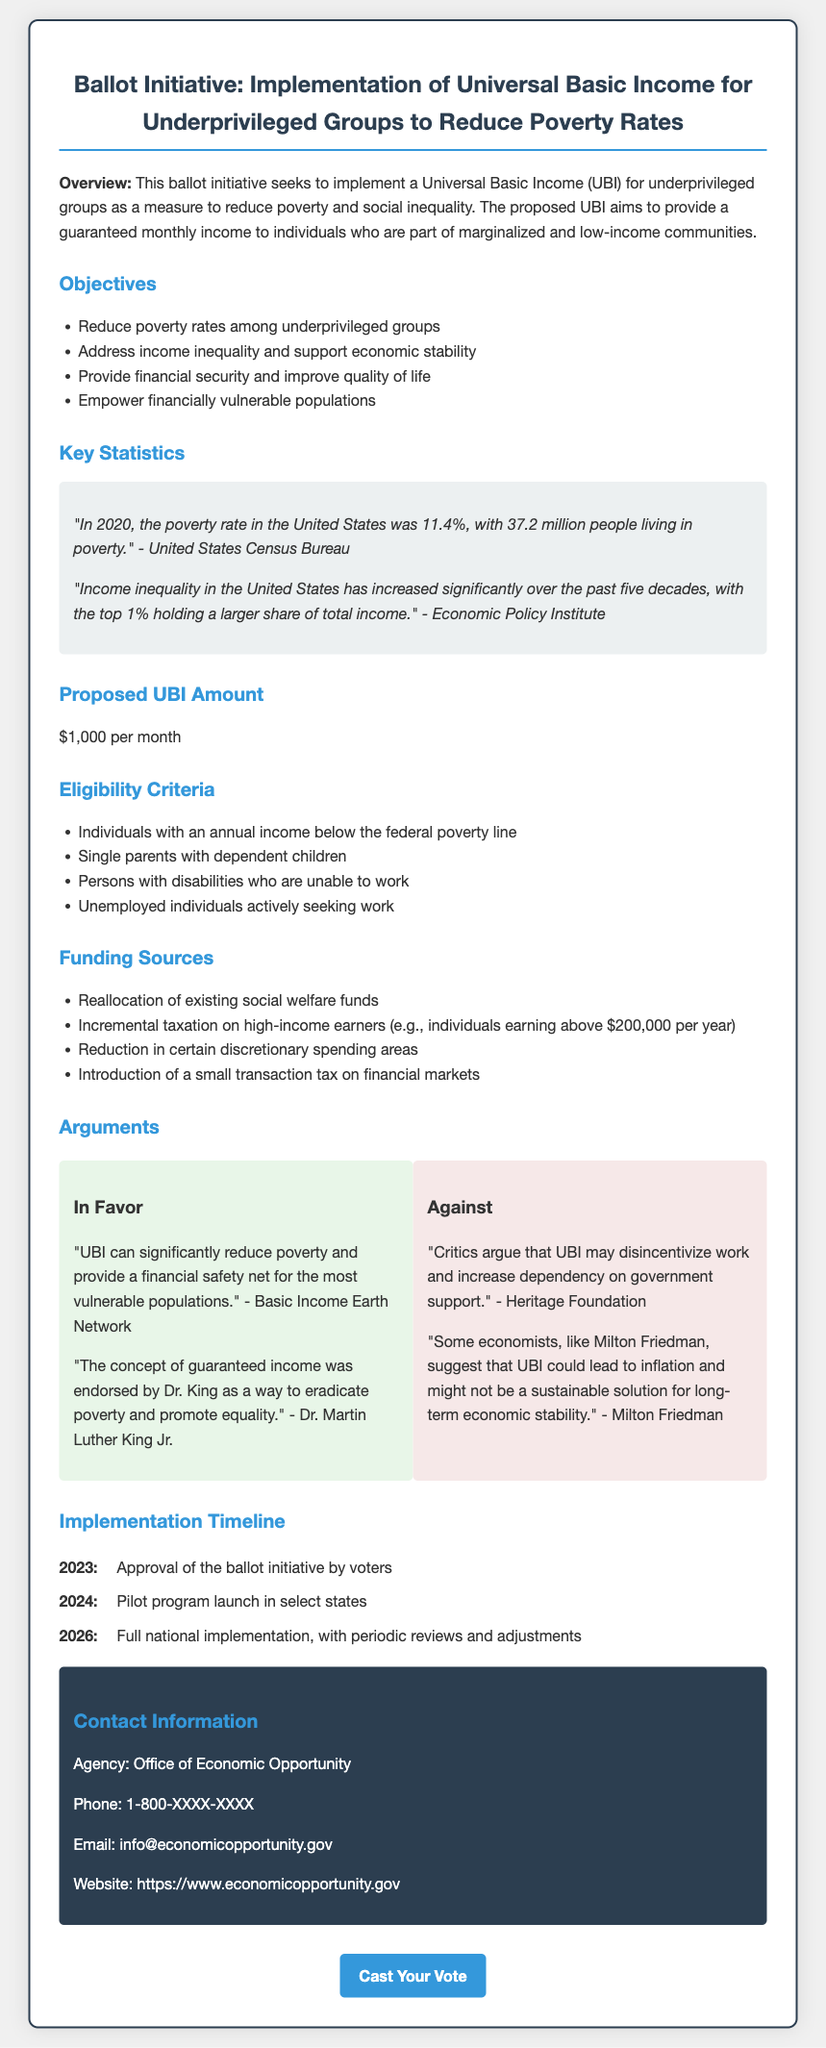What is the proposed UBI amount? The proposed UBI amount is stated in the document under the "Proposed UBI Amount" section.
Answer: $1,000 per month What year is the pilot program scheduled to launch? The pilot program launch date is found in the "Implementation Timeline" section of the document.
Answer: 2024 Who is the agency listed for contact information? The agency name is included in the "Contact Information" section of the document.
Answer: Office of Economic Opportunity What is one of the key objectives of the initiative? The document lists several objectives under the "Objectives" section; an example is presented.
Answer: Reduce poverty rates among underprivileged groups What is one of the funding sources mentioned? The "Funding Sources" section outlines various sources; one is cited in the document.
Answer: Reallocation of existing social welfare funds What is the main argument against UBI? The document provides arguments against UBI in the "Arguments" section, specifying a common concern.
Answer: Disincentivize work What demographic qualifies for the UBI according to eligibility criteria? The "Eligibility Criteria" section details the demographics qualifying for the UBI.
Answer: Individuals with an annual income below the federal poverty line What year marks the full national implementation? The implementation timeline specifies the year for full national implementation.
Answer: 2026 What percentage of the population was living in poverty in 2020? The statistic pertaining to poverty in 2020 is located in the "Key Statistics" section.
Answer: 11.4% 